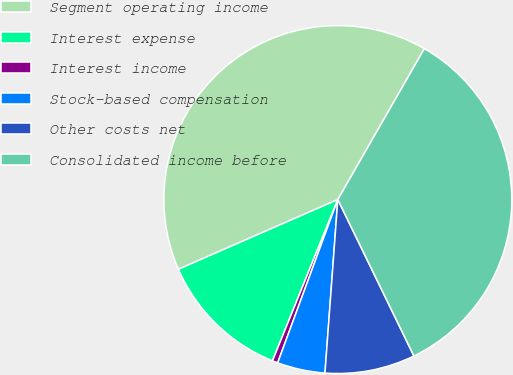<chart> <loc_0><loc_0><loc_500><loc_500><pie_chart><fcel>Segment operating income<fcel>Interest expense<fcel>Interest income<fcel>Stock-based compensation<fcel>Other costs net<fcel>Consolidated income before<nl><fcel>39.85%<fcel>12.31%<fcel>0.51%<fcel>4.44%<fcel>8.38%<fcel>34.51%<nl></chart> 